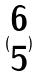<formula> <loc_0><loc_0><loc_500><loc_500>( \begin{matrix} 6 \\ 5 \end{matrix} )</formula> 